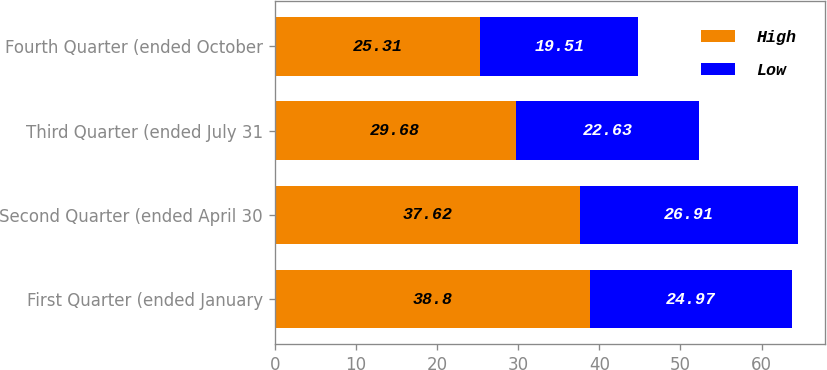Convert chart. <chart><loc_0><loc_0><loc_500><loc_500><stacked_bar_chart><ecel><fcel>First Quarter (ended January<fcel>Second Quarter (ended April 30<fcel>Third Quarter (ended July 31<fcel>Fourth Quarter (ended October<nl><fcel>High<fcel>38.8<fcel>37.62<fcel>29.68<fcel>25.31<nl><fcel>Low<fcel>24.97<fcel>26.91<fcel>22.63<fcel>19.51<nl></chart> 